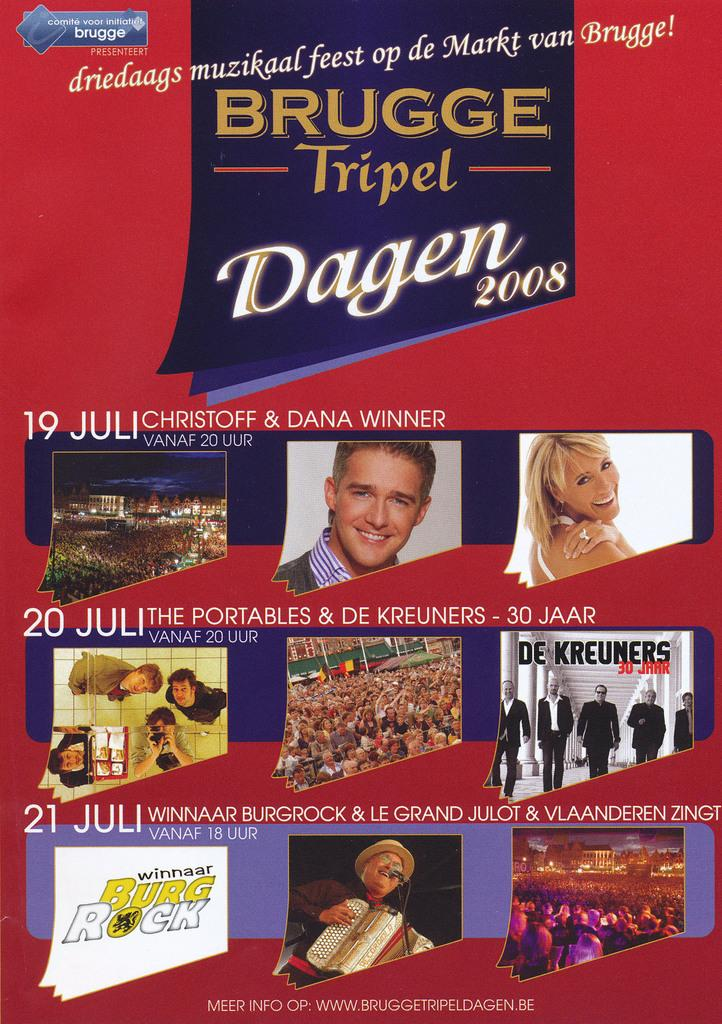What is present in the image? There is a poster in the image. What can be seen on the poster? There are people visible in the poster. How many buildings are visible in the image? There are no buildings visible in the image; it only contains a poster with people. What is the relation between the people in the poster? The relation between the people in the poster cannot be determined from the image alone. 